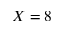<formula> <loc_0><loc_0><loc_500><loc_500>X = 8</formula> 